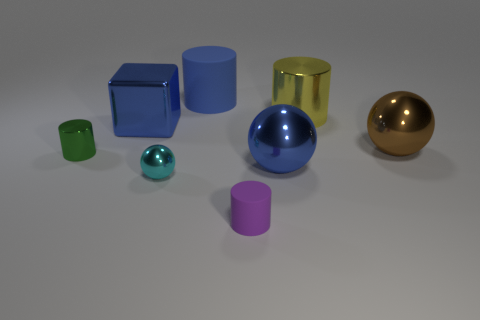Add 1 blue metal blocks. How many objects exist? 9 Subtract all balls. How many objects are left? 5 Subtract all cyan objects. Subtract all purple rubber cylinders. How many objects are left? 6 Add 3 yellow cylinders. How many yellow cylinders are left? 4 Add 4 small cyan things. How many small cyan things exist? 5 Subtract 0 gray cubes. How many objects are left? 8 